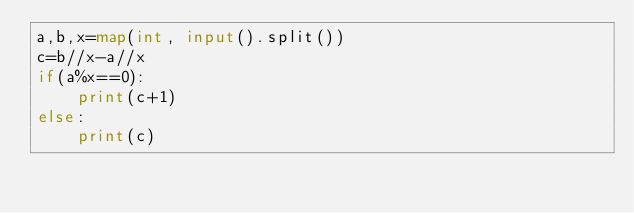Convert code to text. <code><loc_0><loc_0><loc_500><loc_500><_Python_>a,b,x=map(int, input().split())
c=b//x-a//x
if(a%x==0):
    print(c+1)
else:
    print(c)</code> 